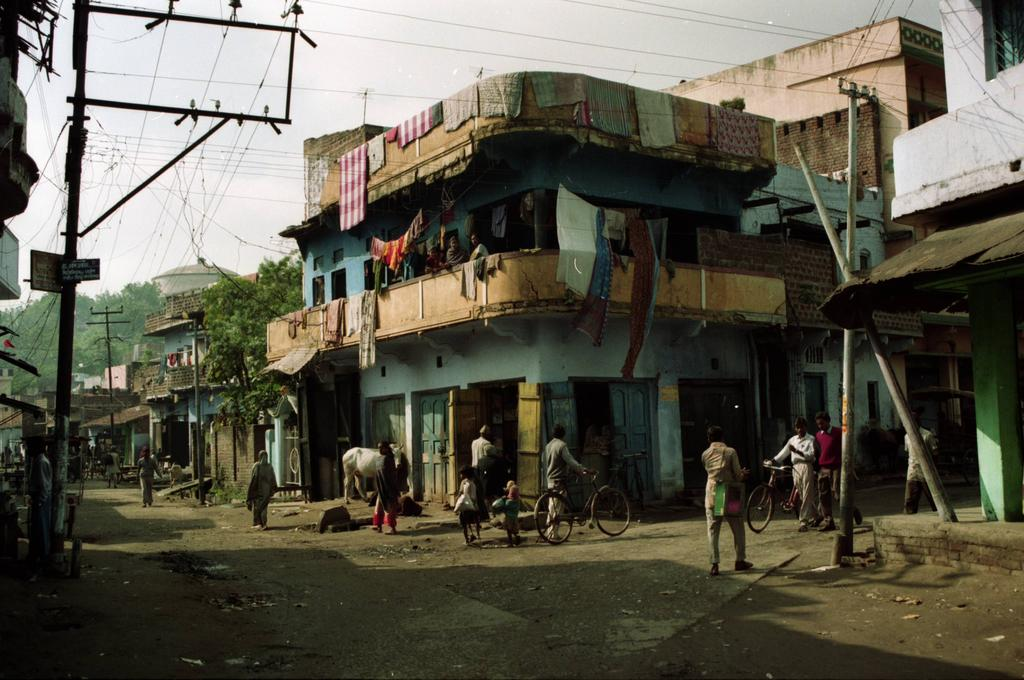What type of structures can be seen in the image? There are buildings in the image. What is the large, vehicle-like object in the image? There is a tank in the image. What type of natural elements are present in the image? There are trees in the image. Where is the electricity pole located in the image? The electricity pole is present on the left side of the image. What are the people in the image doing? People are moving on the road. What are the two men holding in their hands? Two men are holding bicycles in their hands. What type of nation is depicted in the image? The image does not depict a nation; it shows buildings, a tank, trees, an electricity pole, people, and two men holding bicycles. How much salt is present in the image? There is no salt visible in the image. 